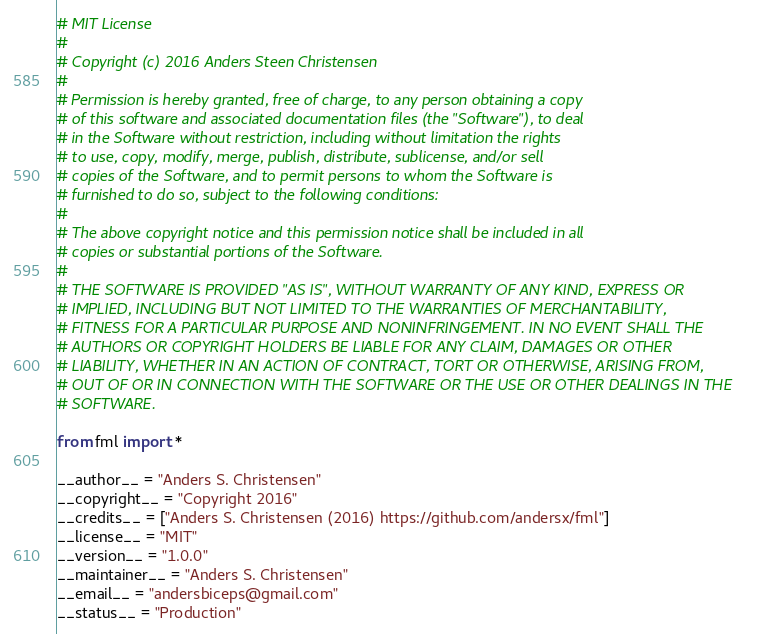Convert code to text. <code><loc_0><loc_0><loc_500><loc_500><_Python_># MIT License
#
# Copyright (c) 2016 Anders Steen Christensen
#
# Permission is hereby granted, free of charge, to any person obtaining a copy
# of this software and associated documentation files (the "Software"), to deal
# in the Software without restriction, including without limitation the rights
# to use, copy, modify, merge, publish, distribute, sublicense, and/or sell
# copies of the Software, and to permit persons to whom the Software is
# furnished to do so, subject to the following conditions:
#
# The above copyright notice and this permission notice shall be included in all
# copies or substantial portions of the Software.
#
# THE SOFTWARE IS PROVIDED "AS IS", WITHOUT WARRANTY OF ANY KIND, EXPRESS OR
# IMPLIED, INCLUDING BUT NOT LIMITED TO THE WARRANTIES OF MERCHANTABILITY,
# FITNESS FOR A PARTICULAR PURPOSE AND NONINFRINGEMENT. IN NO EVENT SHALL THE
# AUTHORS OR COPYRIGHT HOLDERS BE LIABLE FOR ANY CLAIM, DAMAGES OR OTHER
# LIABILITY, WHETHER IN AN ACTION OF CONTRACT, TORT OR OTHERWISE, ARISING FROM,
# OUT OF OR IN CONNECTION WITH THE SOFTWARE OR THE USE OR OTHER DEALINGS IN THE
# SOFTWARE.

from fml import *

__author__ = "Anders S. Christensen"
__copyright__ = "Copyright 2016"
__credits__ = ["Anders S. Christensen (2016) https://github.com/andersx/fml"]
__license__ = "MIT"
__version__ = "1.0.0"
__maintainer__ = "Anders S. Christensen"
__email__ = "andersbiceps@gmail.com"
__status__ = "Production"
</code> 